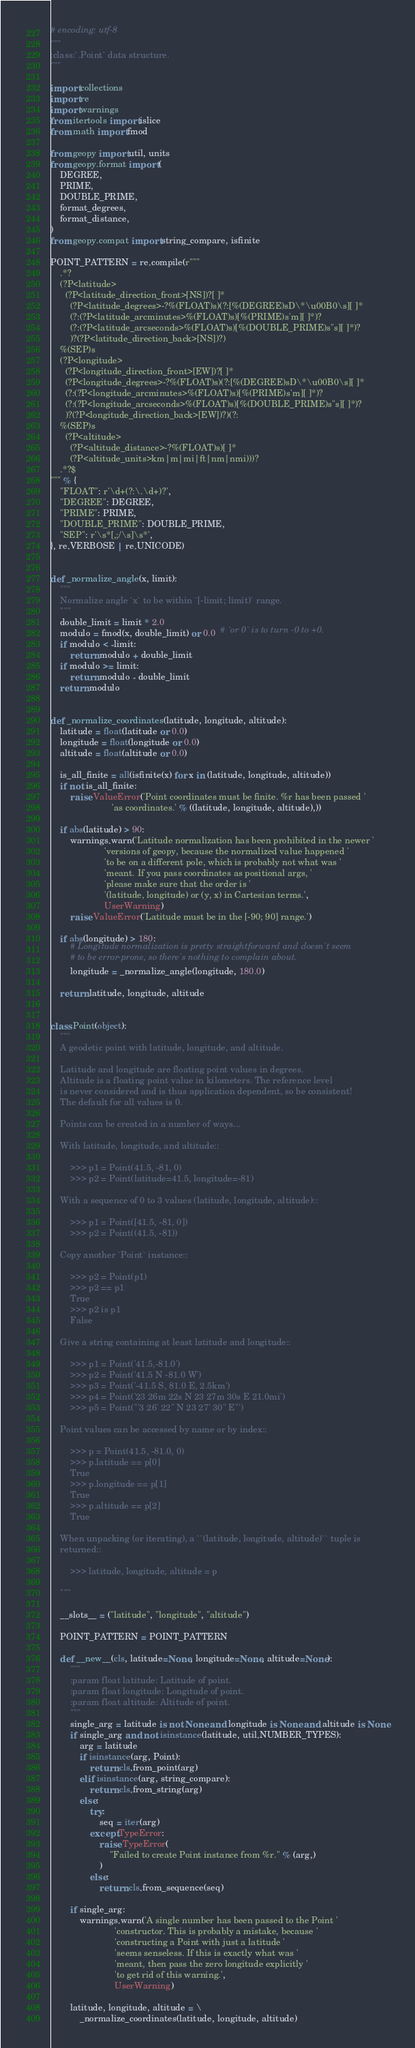<code> <loc_0><loc_0><loc_500><loc_500><_Python_># encoding: utf-8
"""
:class:`.Point` data structure.
"""

import collections
import re
import warnings
from itertools import islice
from math import fmod

from geopy import util, units
from geopy.format import (
    DEGREE,
    PRIME,
    DOUBLE_PRIME,
    format_degrees,
    format_distance,
)
from geopy.compat import string_compare, isfinite

POINT_PATTERN = re.compile(r"""
    .*?
    (?P<latitude>
      (?P<latitude_direction_front>[NS])?[ ]*
        (?P<latitude_degrees>-?%(FLOAT)s)(?:[%(DEGREE)sD\*\u00B0\s][ ]*
        (?:(?P<latitude_arcminutes>%(FLOAT)s)[%(PRIME)s'm][ ]*)?
        (?:(?P<latitude_arcseconds>%(FLOAT)s)[%(DOUBLE_PRIME)s"s][ ]*)?
        )?(?P<latitude_direction_back>[NS])?)
    %(SEP)s
    (?P<longitude>
      (?P<longitude_direction_front>[EW])?[ ]*
      (?P<longitude_degrees>-?%(FLOAT)s)(?:[%(DEGREE)sD\*\u00B0\s][ ]*
      (?:(?P<longitude_arcminutes>%(FLOAT)s)[%(PRIME)s'm][ ]*)?
      (?:(?P<longitude_arcseconds>%(FLOAT)s)[%(DOUBLE_PRIME)s"s][ ]*)?
      )?(?P<longitude_direction_back>[EW])?)(?:
    %(SEP)s
      (?P<altitude>
        (?P<altitude_distance>-?%(FLOAT)s)[ ]*
        (?P<altitude_units>km|m|mi|ft|nm|nmi)))?
    .*?$
""" % {
    "FLOAT": r'\d+(?:\.\d+)?',
    "DEGREE": DEGREE,
    "PRIME": PRIME,
    "DOUBLE_PRIME": DOUBLE_PRIME,
    "SEP": r'\s*[,;/\s]\s*',
}, re.VERBOSE | re.UNICODE)


def _normalize_angle(x, limit):
    """
    Normalize angle `x` to be within `[-limit; limit)` range.
    """
    double_limit = limit * 2.0
    modulo = fmod(x, double_limit) or 0.0  # `or 0` is to turn -0 to +0.
    if modulo < -limit:
        return modulo + double_limit
    if modulo >= limit:
        return modulo - double_limit
    return modulo


def _normalize_coordinates(latitude, longitude, altitude):
    latitude = float(latitude or 0.0)
    longitude = float(longitude or 0.0)
    altitude = float(altitude or 0.0)

    is_all_finite = all(isfinite(x) for x in (latitude, longitude, altitude))
    if not is_all_finite:
        raise ValueError('Point coordinates must be finite. %r has been passed '
                         'as coordinates.' % ((latitude, longitude, altitude),))

    if abs(latitude) > 90:
        warnings.warn('Latitude normalization has been prohibited in the newer '
                      'versions of geopy, because the normalized value happened '
                      'to be on a different pole, which is probably not what was '
                      'meant. If you pass coordinates as positional args, '
                      'please make sure that the order is '
                      '(latitude, longitude) or (y, x) in Cartesian terms.',
                      UserWarning)
        raise ValueError('Latitude must be in the [-90; 90] range.')

    if abs(longitude) > 180:
        # Longitude normalization is pretty straightforward and doesn't seem
        # to be error-prone, so there's nothing to complain about.
        longitude = _normalize_angle(longitude, 180.0)

    return latitude, longitude, altitude


class Point(object):
    """
    A geodetic point with latitude, longitude, and altitude.

    Latitude and longitude are floating point values in degrees.
    Altitude is a floating point value in kilometers. The reference level
    is never considered and is thus application dependent, so be consistent!
    The default for all values is 0.

    Points can be created in a number of ways...

    With latitude, longitude, and altitude::

        >>> p1 = Point(41.5, -81, 0)
        >>> p2 = Point(latitude=41.5, longitude=-81)

    With a sequence of 0 to 3 values (latitude, longitude, altitude)::

        >>> p1 = Point([41.5, -81, 0])
        >>> p2 = Point((41.5, -81))

    Copy another `Point` instance::

        >>> p2 = Point(p1)
        >>> p2 == p1
        True
        >>> p2 is p1
        False

    Give a string containing at least latitude and longitude::

        >>> p1 = Point('41.5,-81.0')
        >>> p2 = Point('41.5 N -81.0 W')
        >>> p3 = Point('-41.5 S, 81.0 E, 2.5km')
        >>> p4 = Point('23 26m 22s N 23 27m 30s E 21.0mi')
        >>> p5 = Point('''3 26' 22" N 23 27' 30" E''')

    Point values can be accessed by name or by index::

        >>> p = Point(41.5, -81.0, 0)
        >>> p.latitude == p[0]
        True
        >>> p.longitude == p[1]
        True
        >>> p.altitude == p[2]
        True

    When unpacking (or iterating), a ``(latitude, longitude, altitude)`` tuple is
    returned::

        >>> latitude, longitude, altitude = p

    """

    __slots__ = ("latitude", "longitude", "altitude")

    POINT_PATTERN = POINT_PATTERN

    def __new__(cls, latitude=None, longitude=None, altitude=None):
        """
        :param float latitude: Latitude of point.
        :param float longitude: Longitude of point.
        :param float altitude: Altitude of point.
        """
        single_arg = latitude is not None and longitude is None and altitude is None
        if single_arg and not isinstance(latitude, util.NUMBER_TYPES):
            arg = latitude
            if isinstance(arg, Point):
                return cls.from_point(arg)
            elif isinstance(arg, string_compare):
                return cls.from_string(arg)
            else:
                try:
                    seq = iter(arg)
                except TypeError:
                    raise TypeError(
                        "Failed to create Point instance from %r." % (arg,)
                    )
                else:
                    return cls.from_sequence(seq)

        if single_arg:
            warnings.warn('A single number has been passed to the Point '
                          'constructor. This is probably a mistake, because '
                          'constructing a Point with just a latitude '
                          'seems senseless. If this is exactly what was '
                          'meant, then pass the zero longitude explicitly '
                          'to get rid of this warning.',
                          UserWarning)

        latitude, longitude, altitude = \
            _normalize_coordinates(latitude, longitude, altitude)
</code> 